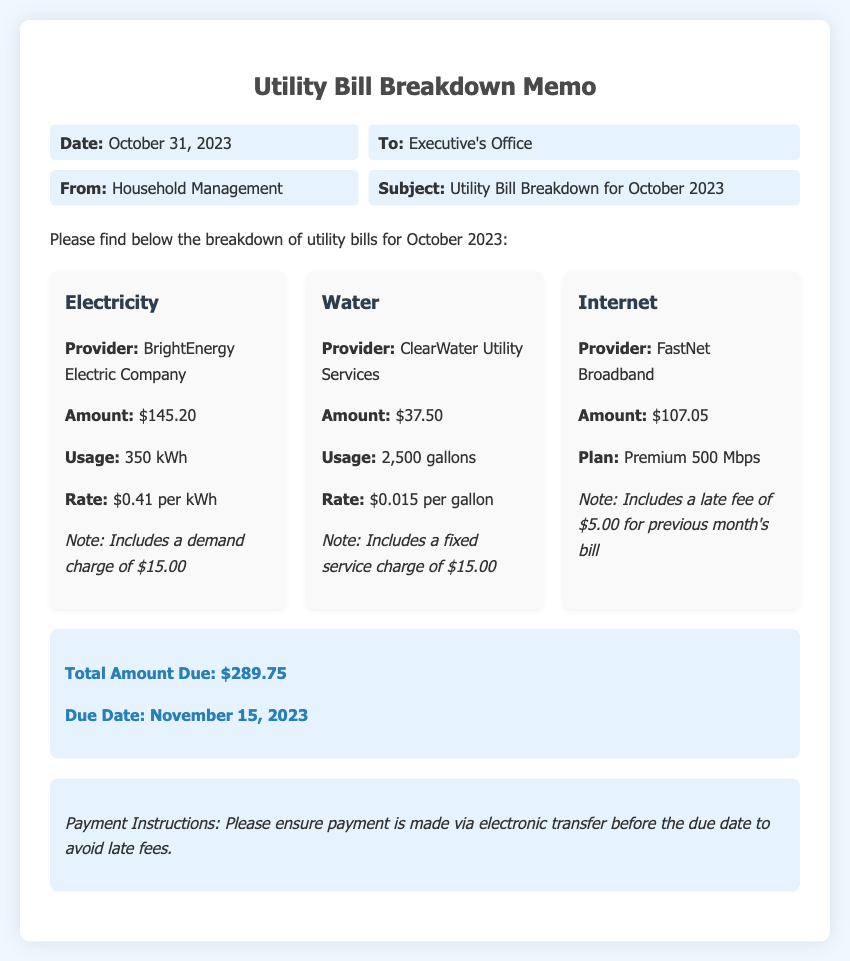what is the total amount due? The total amount due is clearly stated in the document as $289.75.
Answer: $289.75 who is the electricity provider? The electricity provider is mentioned in the utility breakdown section of the document.
Answer: BrightEnergy Electric Company how many gallons of water were used? The document lists the usage for water in the utility breakdown.
Answer: 2,500 gallons what is the due date for the payment? The due date for the payment is specified in the total section of the document.
Answer: November 15, 2023 what was the rate per kWh for electricity? The rate per kWh is provided for electricity in the breakdown.
Answer: $0.41 per kWh what is included in the internet charge? The document notes a specific additional charge that affects the internet billing.
Answer: Late fee of $5.00 what type of memo is this? The title of the document describes its nature.
Answer: Utility Bill Breakdown Memo which utility service has the highest charge? By comparing amounts in the utility breakdown, we can identify the highest charge.
Answer: Internet what is the service charge included in the water bill? The water utility breakdown mentions a specific fixed service charge.
Answer: $15.00 